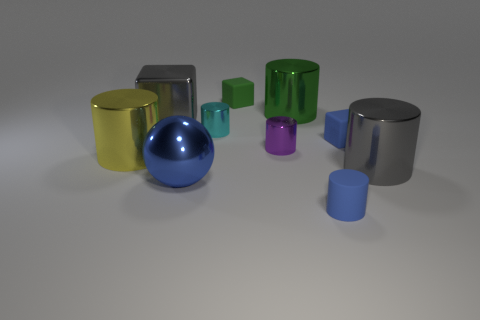Subtract all purple shiny cylinders. How many cylinders are left? 5 Subtract all blue cylinders. How many cylinders are left? 5 Subtract all blocks. How many objects are left? 7 Subtract 3 cylinders. How many cylinders are left? 3 Subtract all brown spheres. Subtract all cyan cubes. How many spheres are left? 1 Subtract all green blocks. How many cyan cylinders are left? 1 Subtract all large blue blocks. Subtract all big spheres. How many objects are left? 9 Add 1 big blue metallic objects. How many big blue metallic objects are left? 2 Add 8 blue matte cylinders. How many blue matte cylinders exist? 9 Subtract 0 cyan blocks. How many objects are left? 10 